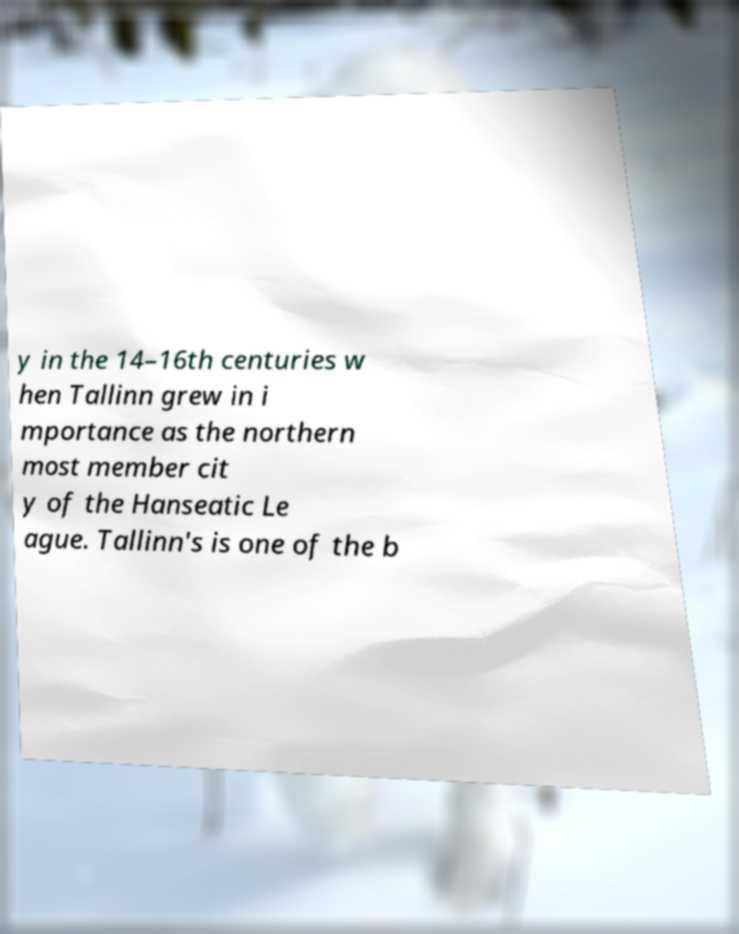Please identify and transcribe the text found in this image. y in the 14–16th centuries w hen Tallinn grew in i mportance as the northern most member cit y of the Hanseatic Le ague. Tallinn's is one of the b 